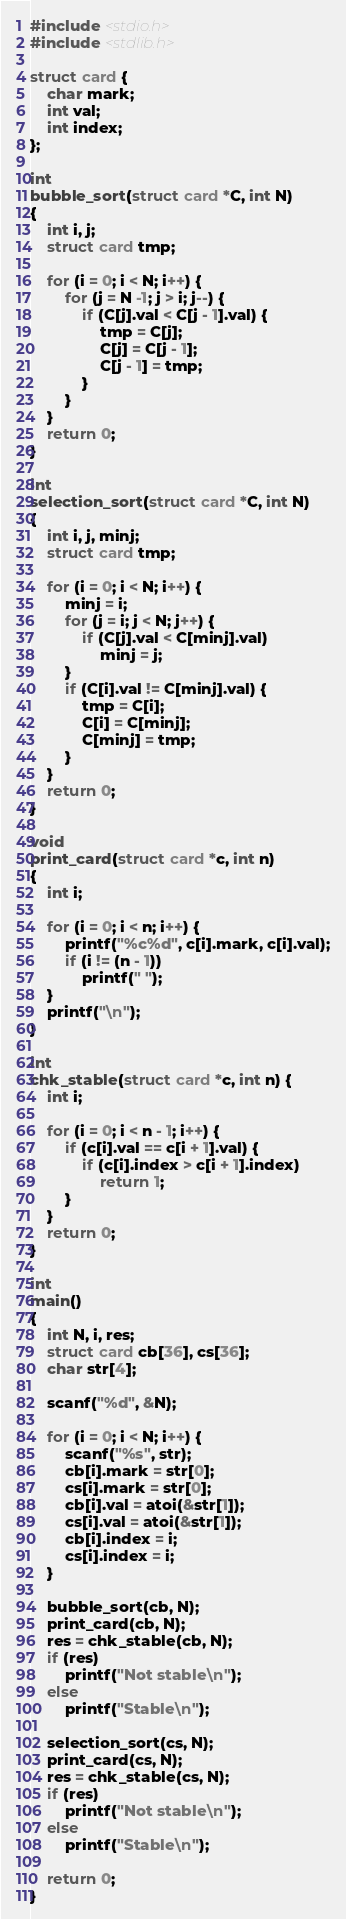Convert code to text. <code><loc_0><loc_0><loc_500><loc_500><_C_>#include <stdio.h>
#include <stdlib.h>

struct card {
    char mark;
    int val;
    int index;
};

int
bubble_sort(struct card *C, int N)
{
    int i, j;
    struct card tmp;

    for (i = 0; i < N; i++) {
        for (j = N -1; j > i; j--) {
            if (C[j].val < C[j - 1].val) {
                tmp = C[j];
                C[j] = C[j - 1];
                C[j - 1] = tmp;
            }
        }
    }
    return 0;
}

int
selection_sort(struct card *C, int N)
{
    int i, j, minj;
    struct card tmp;

    for (i = 0; i < N; i++) {
        minj = i;
        for (j = i; j < N; j++) {
            if (C[j].val < C[minj].val)
                minj = j;
        }
        if (C[i].val != C[minj].val) {
            tmp = C[i];
            C[i] = C[minj];
            C[minj] = tmp;
        }
    }
    return 0;
}

void
print_card(struct card *c, int n)
{
    int i;

    for (i = 0; i < n; i++) {
        printf("%c%d", c[i].mark, c[i].val);
        if (i != (n - 1))
            printf(" ");
    }
    printf("\n");
}

int
chk_stable(struct card *c, int n) {
    int i;

    for (i = 0; i < n - 1; i++) {
        if (c[i].val == c[i + 1].val) {
            if (c[i].index > c[i + 1].index)
                return 1;
        }
    }
    return 0;
}

int
main()
{
    int N, i, res;
    struct card cb[36], cs[36];
    char str[4];

    scanf("%d", &N);

    for (i = 0; i < N; i++) {
        scanf("%s", str);
        cb[i].mark = str[0];
        cs[i].mark = str[0];
        cb[i].val = atoi(&str[1]);
        cs[i].val = atoi(&str[1]);
        cb[i].index = i;
        cs[i].index = i;
    }

    bubble_sort(cb, N);
    print_card(cb, N);
    res = chk_stable(cb, N);
    if (res)
        printf("Not stable\n");
    else
        printf("Stable\n");

    selection_sort(cs, N);
    print_card(cs, N);
    res = chk_stable(cs, N);
    if (res)
        printf("Not stable\n");
    else
        printf("Stable\n");

    return 0;
}
</code> 